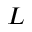Convert formula to latex. <formula><loc_0><loc_0><loc_500><loc_500>L</formula> 